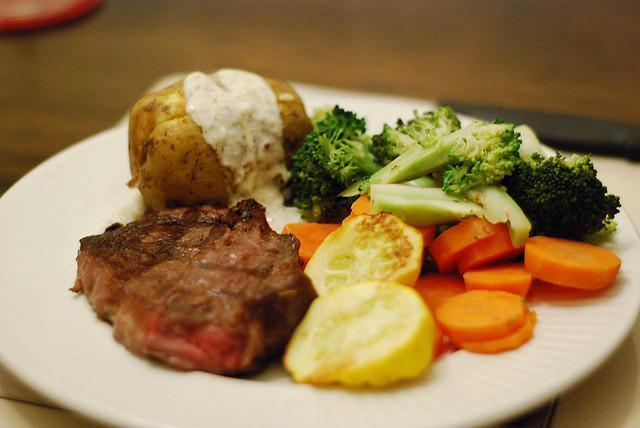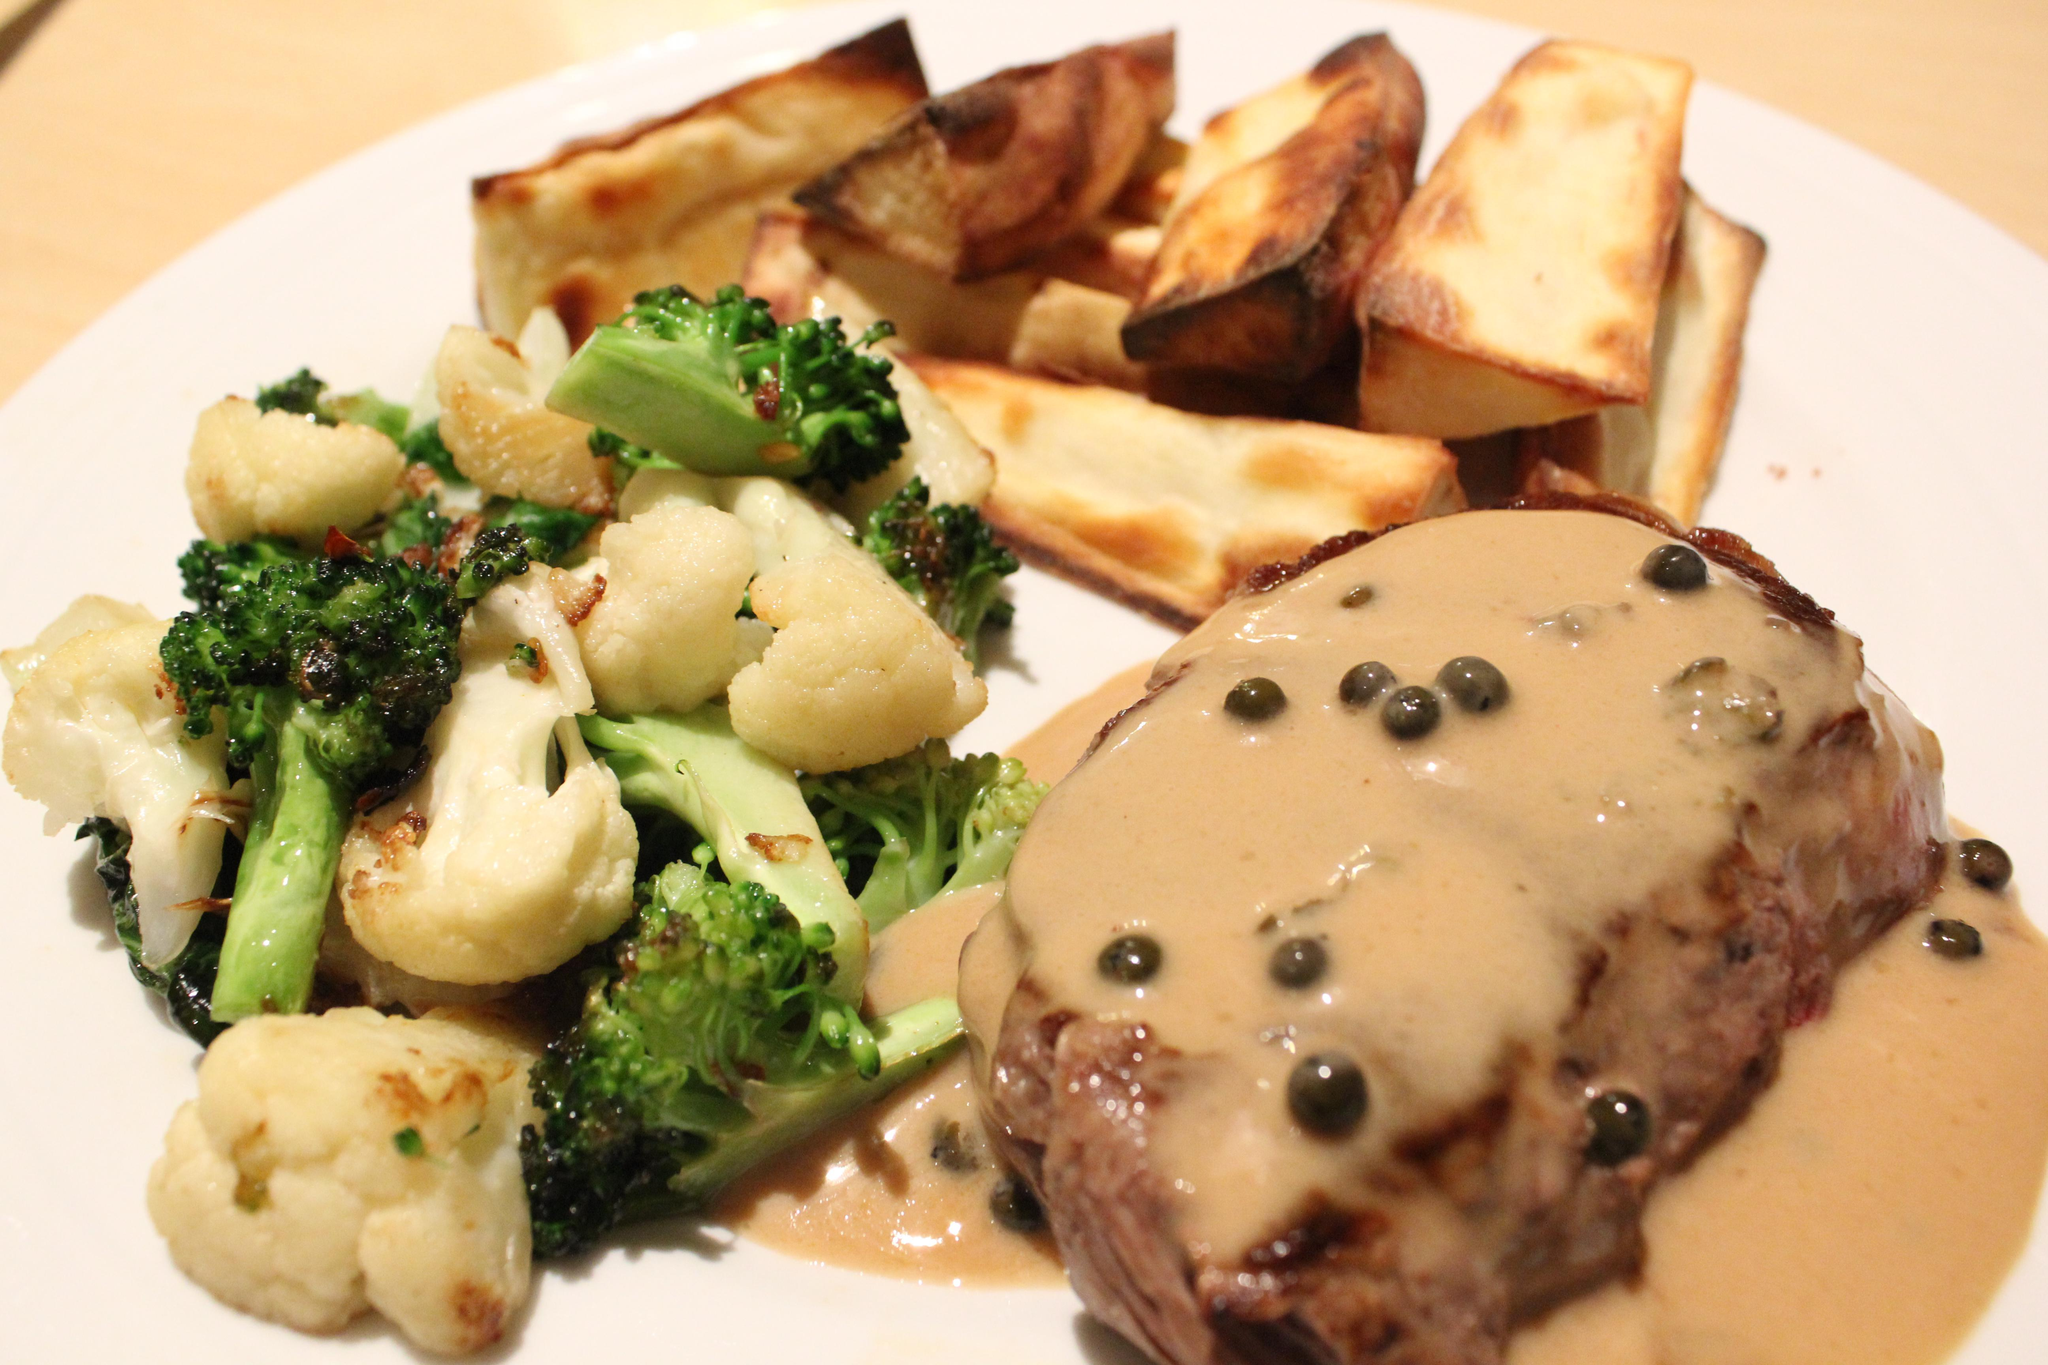The first image is the image on the left, the second image is the image on the right. For the images displayed, is the sentence "There are carrots on the plate in the image on the left." factually correct? Answer yes or no. Yes. 